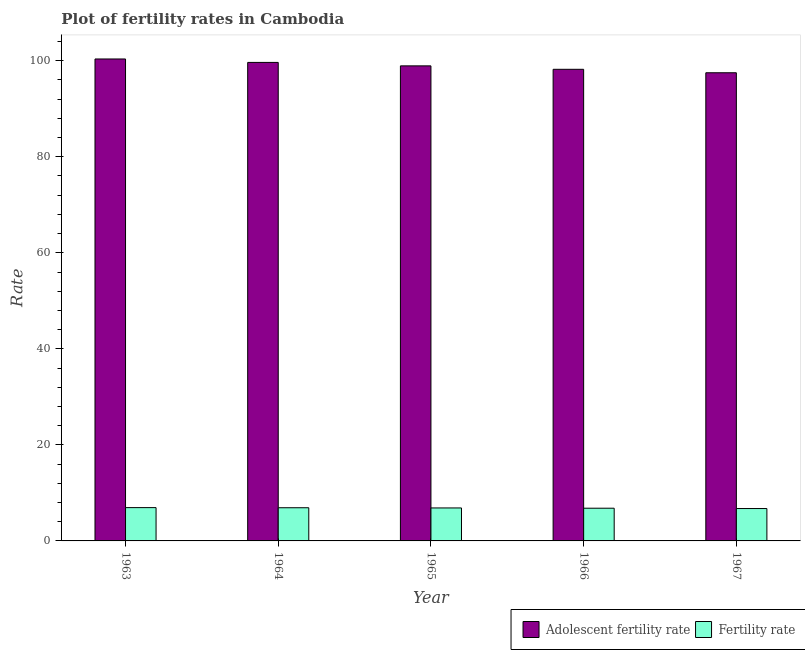How many groups of bars are there?
Your answer should be compact. 5. Are the number of bars per tick equal to the number of legend labels?
Offer a very short reply. Yes. How many bars are there on the 3rd tick from the right?
Your answer should be very brief. 2. What is the label of the 4th group of bars from the left?
Offer a very short reply. 1966. In how many cases, is the number of bars for a given year not equal to the number of legend labels?
Offer a terse response. 0. What is the fertility rate in 1964?
Offer a terse response. 6.91. Across all years, what is the maximum adolescent fertility rate?
Keep it short and to the point. 100.36. Across all years, what is the minimum adolescent fertility rate?
Make the answer very short. 97.49. In which year was the fertility rate minimum?
Offer a terse response. 1967. What is the total fertility rate in the graph?
Your response must be concise. 34.27. What is the difference between the adolescent fertility rate in 1965 and that in 1966?
Provide a succinct answer. 0.72. What is the difference between the fertility rate in 1963 and the adolescent fertility rate in 1967?
Offer a terse response. 0.19. What is the average fertility rate per year?
Give a very brief answer. 6.85. What is the ratio of the fertility rate in 1963 to that in 1965?
Offer a very short reply. 1.01. Is the fertility rate in 1964 less than that in 1966?
Offer a very short reply. No. What is the difference between the highest and the second highest adolescent fertility rate?
Provide a succinct answer. 0.72. What is the difference between the highest and the lowest adolescent fertility rate?
Provide a succinct answer. 2.87. Is the sum of the adolescent fertility rate in 1963 and 1964 greater than the maximum fertility rate across all years?
Give a very brief answer. Yes. What does the 2nd bar from the left in 1966 represents?
Provide a succinct answer. Fertility rate. What does the 2nd bar from the right in 1965 represents?
Your answer should be very brief. Adolescent fertility rate. What is the difference between two consecutive major ticks on the Y-axis?
Keep it short and to the point. 20. Does the graph contain any zero values?
Keep it short and to the point. No. Where does the legend appear in the graph?
Ensure brevity in your answer.  Bottom right. What is the title of the graph?
Your response must be concise. Plot of fertility rates in Cambodia. What is the label or title of the Y-axis?
Your response must be concise. Rate. What is the Rate of Adolescent fertility rate in 1963?
Your answer should be very brief. 100.36. What is the Rate in Fertility rate in 1963?
Offer a very short reply. 6.94. What is the Rate in Adolescent fertility rate in 1964?
Give a very brief answer. 99.65. What is the Rate in Fertility rate in 1964?
Provide a short and direct response. 6.91. What is the Rate of Adolescent fertility rate in 1965?
Give a very brief answer. 98.93. What is the Rate in Fertility rate in 1965?
Provide a short and direct response. 6.87. What is the Rate in Adolescent fertility rate in 1966?
Your answer should be compact. 98.21. What is the Rate of Fertility rate in 1966?
Your answer should be very brief. 6.81. What is the Rate of Adolescent fertility rate in 1967?
Offer a very short reply. 97.49. What is the Rate of Fertility rate in 1967?
Give a very brief answer. 6.75. Across all years, what is the maximum Rate in Adolescent fertility rate?
Provide a succinct answer. 100.36. Across all years, what is the maximum Rate in Fertility rate?
Your response must be concise. 6.94. Across all years, what is the minimum Rate in Adolescent fertility rate?
Give a very brief answer. 97.49. Across all years, what is the minimum Rate in Fertility rate?
Offer a terse response. 6.75. What is the total Rate in Adolescent fertility rate in the graph?
Your answer should be very brief. 494.64. What is the total Rate of Fertility rate in the graph?
Your answer should be very brief. 34.27. What is the difference between the Rate of Adolescent fertility rate in 1963 and that in 1964?
Provide a succinct answer. 0.72. What is the difference between the Rate in Fertility rate in 1963 and that in 1964?
Give a very brief answer. 0.03. What is the difference between the Rate of Adolescent fertility rate in 1963 and that in 1965?
Ensure brevity in your answer.  1.43. What is the difference between the Rate in Fertility rate in 1963 and that in 1965?
Ensure brevity in your answer.  0.07. What is the difference between the Rate of Adolescent fertility rate in 1963 and that in 1966?
Keep it short and to the point. 2.15. What is the difference between the Rate in Fertility rate in 1963 and that in 1966?
Provide a short and direct response. 0.12. What is the difference between the Rate in Adolescent fertility rate in 1963 and that in 1967?
Give a very brief answer. 2.87. What is the difference between the Rate in Fertility rate in 1963 and that in 1967?
Offer a very short reply. 0.19. What is the difference between the Rate in Adolescent fertility rate in 1964 and that in 1965?
Keep it short and to the point. 0.72. What is the difference between the Rate in Fertility rate in 1964 and that in 1965?
Make the answer very short. 0.04. What is the difference between the Rate of Adolescent fertility rate in 1964 and that in 1966?
Provide a short and direct response. 1.43. What is the difference between the Rate in Fertility rate in 1964 and that in 1966?
Offer a terse response. 0.1. What is the difference between the Rate of Adolescent fertility rate in 1964 and that in 1967?
Ensure brevity in your answer.  2.15. What is the difference between the Rate of Fertility rate in 1964 and that in 1967?
Your response must be concise. 0.16. What is the difference between the Rate in Adolescent fertility rate in 1965 and that in 1966?
Provide a succinct answer. 0.72. What is the difference between the Rate of Fertility rate in 1965 and that in 1966?
Provide a short and direct response. 0.06. What is the difference between the Rate in Adolescent fertility rate in 1965 and that in 1967?
Provide a short and direct response. 1.43. What is the difference between the Rate in Fertility rate in 1965 and that in 1967?
Offer a terse response. 0.12. What is the difference between the Rate in Adolescent fertility rate in 1966 and that in 1967?
Offer a very short reply. 0.72. What is the difference between the Rate of Fertility rate in 1966 and that in 1967?
Your answer should be compact. 0.07. What is the difference between the Rate in Adolescent fertility rate in 1963 and the Rate in Fertility rate in 1964?
Provide a short and direct response. 93.45. What is the difference between the Rate in Adolescent fertility rate in 1963 and the Rate in Fertility rate in 1965?
Your answer should be compact. 93.5. What is the difference between the Rate in Adolescent fertility rate in 1963 and the Rate in Fertility rate in 1966?
Your response must be concise. 93.55. What is the difference between the Rate of Adolescent fertility rate in 1963 and the Rate of Fertility rate in 1967?
Offer a terse response. 93.62. What is the difference between the Rate of Adolescent fertility rate in 1964 and the Rate of Fertility rate in 1965?
Offer a very short reply. 92.78. What is the difference between the Rate in Adolescent fertility rate in 1964 and the Rate in Fertility rate in 1966?
Offer a very short reply. 92.83. What is the difference between the Rate of Adolescent fertility rate in 1964 and the Rate of Fertility rate in 1967?
Keep it short and to the point. 92.9. What is the difference between the Rate of Adolescent fertility rate in 1965 and the Rate of Fertility rate in 1966?
Your answer should be very brief. 92.12. What is the difference between the Rate of Adolescent fertility rate in 1965 and the Rate of Fertility rate in 1967?
Your response must be concise. 92.18. What is the difference between the Rate in Adolescent fertility rate in 1966 and the Rate in Fertility rate in 1967?
Provide a succinct answer. 91.47. What is the average Rate in Adolescent fertility rate per year?
Your answer should be compact. 98.93. What is the average Rate in Fertility rate per year?
Ensure brevity in your answer.  6.85. In the year 1963, what is the difference between the Rate in Adolescent fertility rate and Rate in Fertility rate?
Offer a very short reply. 93.43. In the year 1964, what is the difference between the Rate of Adolescent fertility rate and Rate of Fertility rate?
Offer a very short reply. 92.74. In the year 1965, what is the difference between the Rate of Adolescent fertility rate and Rate of Fertility rate?
Give a very brief answer. 92.06. In the year 1966, what is the difference between the Rate of Adolescent fertility rate and Rate of Fertility rate?
Ensure brevity in your answer.  91.4. In the year 1967, what is the difference between the Rate of Adolescent fertility rate and Rate of Fertility rate?
Offer a very short reply. 90.75. What is the ratio of the Rate in Adolescent fertility rate in 1963 to that in 1964?
Your response must be concise. 1.01. What is the ratio of the Rate in Fertility rate in 1963 to that in 1964?
Ensure brevity in your answer.  1. What is the ratio of the Rate in Adolescent fertility rate in 1963 to that in 1965?
Offer a very short reply. 1.01. What is the ratio of the Rate of Fertility rate in 1963 to that in 1965?
Keep it short and to the point. 1.01. What is the ratio of the Rate in Adolescent fertility rate in 1963 to that in 1966?
Provide a short and direct response. 1.02. What is the ratio of the Rate of Fertility rate in 1963 to that in 1966?
Provide a succinct answer. 1.02. What is the ratio of the Rate of Adolescent fertility rate in 1963 to that in 1967?
Offer a very short reply. 1.03. What is the ratio of the Rate of Fertility rate in 1963 to that in 1967?
Keep it short and to the point. 1.03. What is the ratio of the Rate of Adolescent fertility rate in 1964 to that in 1965?
Make the answer very short. 1.01. What is the ratio of the Rate of Fertility rate in 1964 to that in 1965?
Offer a very short reply. 1.01. What is the ratio of the Rate in Adolescent fertility rate in 1964 to that in 1966?
Your response must be concise. 1.01. What is the ratio of the Rate of Fertility rate in 1964 to that in 1966?
Your response must be concise. 1.01. What is the ratio of the Rate of Adolescent fertility rate in 1964 to that in 1967?
Keep it short and to the point. 1.02. What is the ratio of the Rate of Fertility rate in 1964 to that in 1967?
Offer a very short reply. 1.02. What is the ratio of the Rate in Adolescent fertility rate in 1965 to that in 1966?
Keep it short and to the point. 1.01. What is the ratio of the Rate of Fertility rate in 1965 to that in 1966?
Offer a terse response. 1.01. What is the ratio of the Rate in Adolescent fertility rate in 1965 to that in 1967?
Make the answer very short. 1.01. What is the ratio of the Rate of Fertility rate in 1965 to that in 1967?
Offer a very short reply. 1.02. What is the ratio of the Rate of Adolescent fertility rate in 1966 to that in 1967?
Your answer should be compact. 1.01. What is the difference between the highest and the second highest Rate of Adolescent fertility rate?
Provide a short and direct response. 0.72. What is the difference between the highest and the second highest Rate of Fertility rate?
Your answer should be compact. 0.03. What is the difference between the highest and the lowest Rate of Adolescent fertility rate?
Offer a very short reply. 2.87. What is the difference between the highest and the lowest Rate in Fertility rate?
Keep it short and to the point. 0.19. 